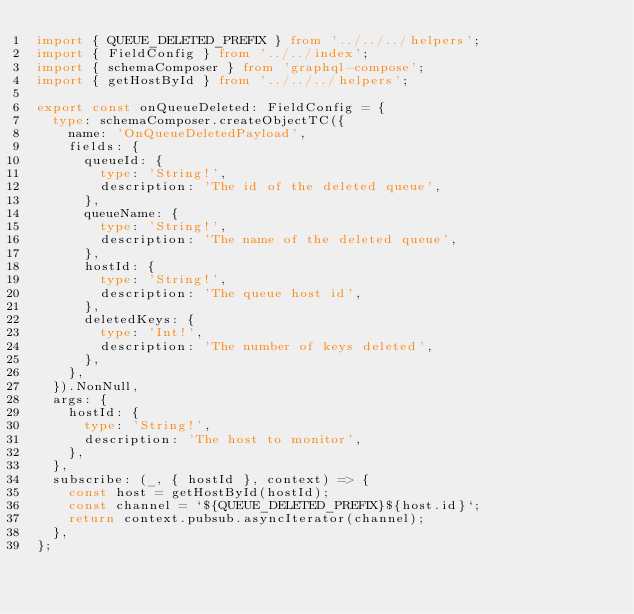Convert code to text. <code><loc_0><loc_0><loc_500><loc_500><_TypeScript_>import { QUEUE_DELETED_PREFIX } from '../../../helpers';
import { FieldConfig } from '../../index';
import { schemaComposer } from 'graphql-compose';
import { getHostById } from '../../../helpers';

export const onQueueDeleted: FieldConfig = {
  type: schemaComposer.createObjectTC({
    name: 'OnQueueDeletedPayload',
    fields: {
      queueId: {
        type: 'String!',
        description: 'The id of the deleted queue',
      },
      queueName: {
        type: 'String!',
        description: 'The name of the deleted queue',
      },
      hostId: {
        type: 'String!',
        description: 'The queue host id',
      },
      deletedKeys: {
        type: 'Int!',
        description: 'The number of keys deleted',
      },
    },
  }).NonNull,
  args: {
    hostId: {
      type: 'String!',
      description: 'The host to monitor',
    },
  },
  subscribe: (_, { hostId }, context) => {
    const host = getHostById(hostId);
    const channel = `${QUEUE_DELETED_PREFIX}${host.id}`;
    return context.pubsub.asyncIterator(channel);
  },
};
</code> 